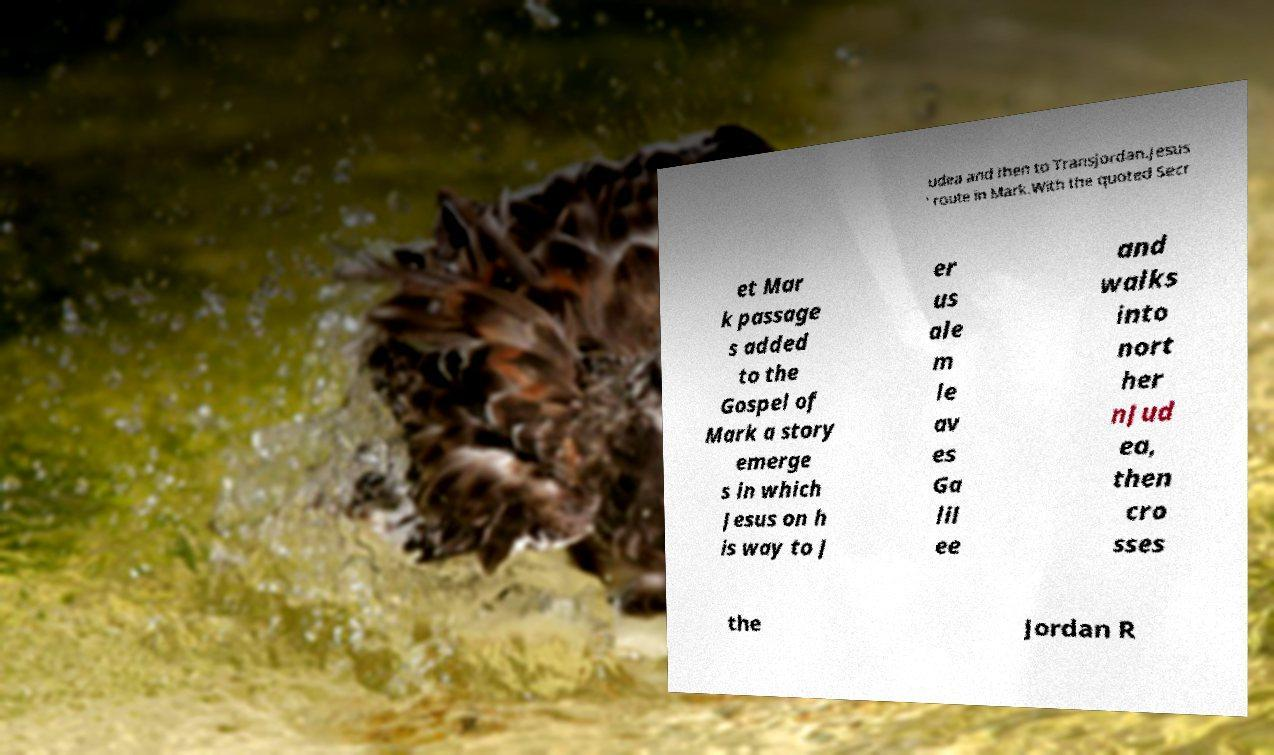For documentation purposes, I need the text within this image transcribed. Could you provide that? udea and then to Transjordan.Jesus ' route in Mark.With the quoted Secr et Mar k passage s added to the Gospel of Mark a story emerge s in which Jesus on h is way to J er us ale m le av es Ga lil ee and walks into nort her nJud ea, then cro sses the Jordan R 